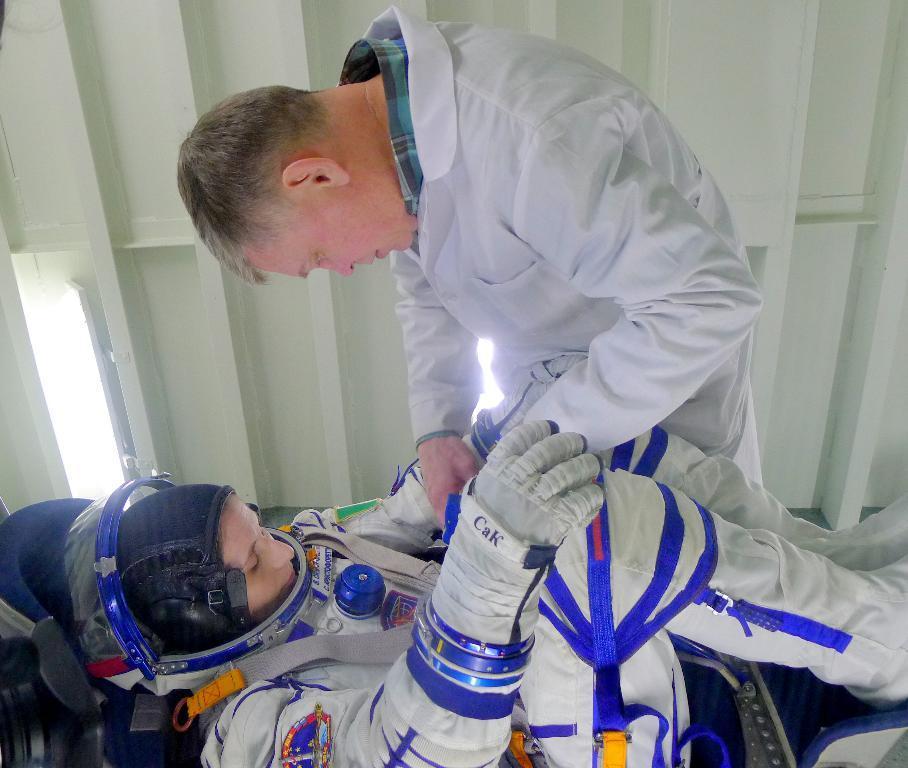Can you describe this image briefly? In this picture there is a girl wearing white color astronaut dress lying on the chair. In front there is a man wearing white color doctor coat is adjusting the astronaut dress. Behind there is a iron shed. 